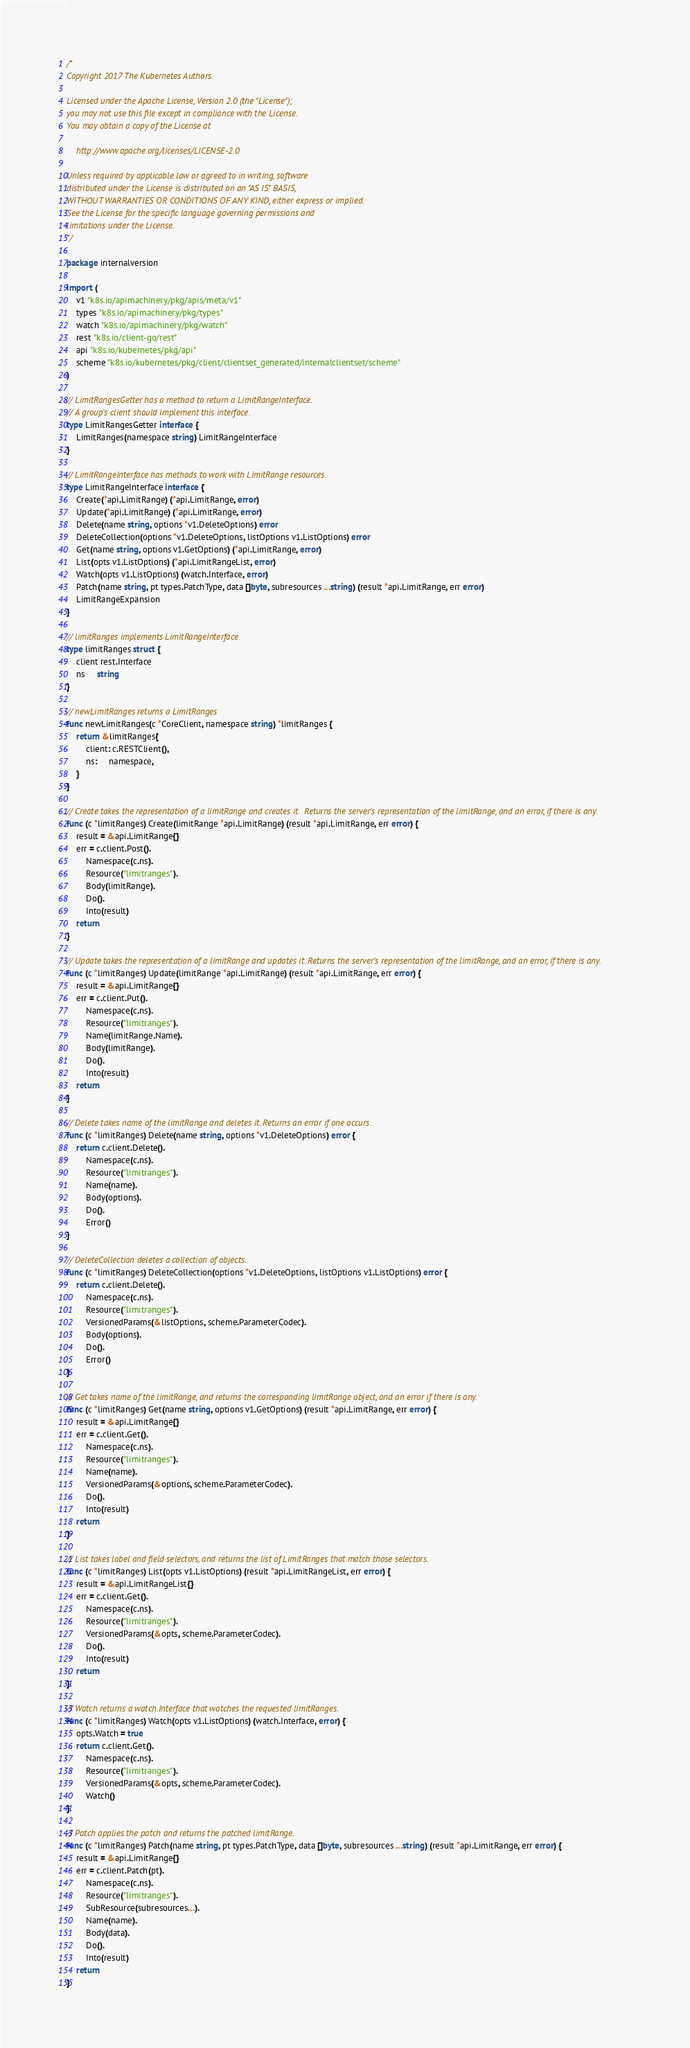Convert code to text. <code><loc_0><loc_0><loc_500><loc_500><_Go_>/*
Copyright 2017 The Kubernetes Authors.

Licensed under the Apache License, Version 2.0 (the "License");
you may not use this file except in compliance with the License.
You may obtain a copy of the License at

    http://www.apache.org/licenses/LICENSE-2.0

Unless required by applicable law or agreed to in writing, software
distributed under the License is distributed on an "AS IS" BASIS,
WITHOUT WARRANTIES OR CONDITIONS OF ANY KIND, either express or implied.
See the License for the specific language governing permissions and
limitations under the License.
*/

package internalversion

import (
	v1 "k8s.io/apimachinery/pkg/apis/meta/v1"
	types "k8s.io/apimachinery/pkg/types"
	watch "k8s.io/apimachinery/pkg/watch"
	rest "k8s.io/client-go/rest"
	api "k8s.io/kubernetes/pkg/api"
	scheme "k8s.io/kubernetes/pkg/client/clientset_generated/internalclientset/scheme"
)

// LimitRangesGetter has a method to return a LimitRangeInterface.
// A group's client should implement this interface.
type LimitRangesGetter interface {
	LimitRanges(namespace string) LimitRangeInterface
}

// LimitRangeInterface has methods to work with LimitRange resources.
type LimitRangeInterface interface {
	Create(*api.LimitRange) (*api.LimitRange, error)
	Update(*api.LimitRange) (*api.LimitRange, error)
	Delete(name string, options *v1.DeleteOptions) error
	DeleteCollection(options *v1.DeleteOptions, listOptions v1.ListOptions) error
	Get(name string, options v1.GetOptions) (*api.LimitRange, error)
	List(opts v1.ListOptions) (*api.LimitRangeList, error)
	Watch(opts v1.ListOptions) (watch.Interface, error)
	Patch(name string, pt types.PatchType, data []byte, subresources ...string) (result *api.LimitRange, err error)
	LimitRangeExpansion
}

// limitRanges implements LimitRangeInterface
type limitRanges struct {
	client rest.Interface
	ns     string
}

// newLimitRanges returns a LimitRanges
func newLimitRanges(c *CoreClient, namespace string) *limitRanges {
	return &limitRanges{
		client: c.RESTClient(),
		ns:     namespace,
	}
}

// Create takes the representation of a limitRange and creates it.  Returns the server's representation of the limitRange, and an error, if there is any.
func (c *limitRanges) Create(limitRange *api.LimitRange) (result *api.LimitRange, err error) {
	result = &api.LimitRange{}
	err = c.client.Post().
		Namespace(c.ns).
		Resource("limitranges").
		Body(limitRange).
		Do().
		Into(result)
	return
}

// Update takes the representation of a limitRange and updates it. Returns the server's representation of the limitRange, and an error, if there is any.
func (c *limitRanges) Update(limitRange *api.LimitRange) (result *api.LimitRange, err error) {
	result = &api.LimitRange{}
	err = c.client.Put().
		Namespace(c.ns).
		Resource("limitranges").
		Name(limitRange.Name).
		Body(limitRange).
		Do().
		Into(result)
	return
}

// Delete takes name of the limitRange and deletes it. Returns an error if one occurs.
func (c *limitRanges) Delete(name string, options *v1.DeleteOptions) error {
	return c.client.Delete().
		Namespace(c.ns).
		Resource("limitranges").
		Name(name).
		Body(options).
		Do().
		Error()
}

// DeleteCollection deletes a collection of objects.
func (c *limitRanges) DeleteCollection(options *v1.DeleteOptions, listOptions v1.ListOptions) error {
	return c.client.Delete().
		Namespace(c.ns).
		Resource("limitranges").
		VersionedParams(&listOptions, scheme.ParameterCodec).
		Body(options).
		Do().
		Error()
}

// Get takes name of the limitRange, and returns the corresponding limitRange object, and an error if there is any.
func (c *limitRanges) Get(name string, options v1.GetOptions) (result *api.LimitRange, err error) {
	result = &api.LimitRange{}
	err = c.client.Get().
		Namespace(c.ns).
		Resource("limitranges").
		Name(name).
		VersionedParams(&options, scheme.ParameterCodec).
		Do().
		Into(result)
	return
}

// List takes label and field selectors, and returns the list of LimitRanges that match those selectors.
func (c *limitRanges) List(opts v1.ListOptions) (result *api.LimitRangeList, err error) {
	result = &api.LimitRangeList{}
	err = c.client.Get().
		Namespace(c.ns).
		Resource("limitranges").
		VersionedParams(&opts, scheme.ParameterCodec).
		Do().
		Into(result)
	return
}

// Watch returns a watch.Interface that watches the requested limitRanges.
func (c *limitRanges) Watch(opts v1.ListOptions) (watch.Interface, error) {
	opts.Watch = true
	return c.client.Get().
		Namespace(c.ns).
		Resource("limitranges").
		VersionedParams(&opts, scheme.ParameterCodec).
		Watch()
}

// Patch applies the patch and returns the patched limitRange.
func (c *limitRanges) Patch(name string, pt types.PatchType, data []byte, subresources ...string) (result *api.LimitRange, err error) {
	result = &api.LimitRange{}
	err = c.client.Patch(pt).
		Namespace(c.ns).
		Resource("limitranges").
		SubResource(subresources...).
		Name(name).
		Body(data).
		Do().
		Into(result)
	return
}
</code> 